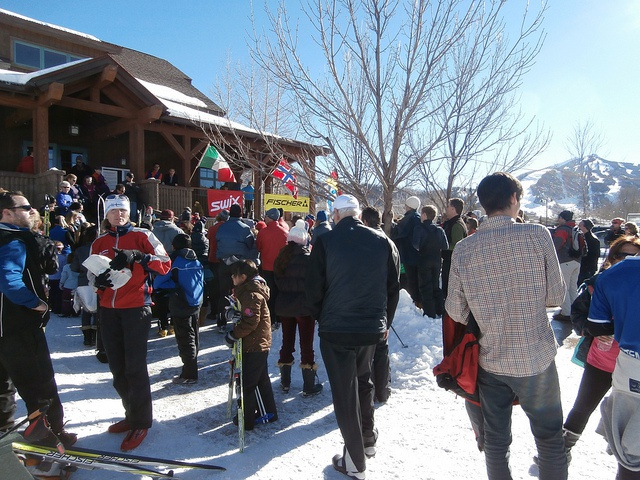Describe the objects in this image and their specific colors. I can see people in lightblue, black, gray, darkgray, and white tones, people in lightblue, gray, and black tones, people in lightblue, black, gray, darkgray, and white tones, people in lightblue, black, maroon, gray, and darkgray tones, and people in lightblue, black, navy, gray, and blue tones in this image. 